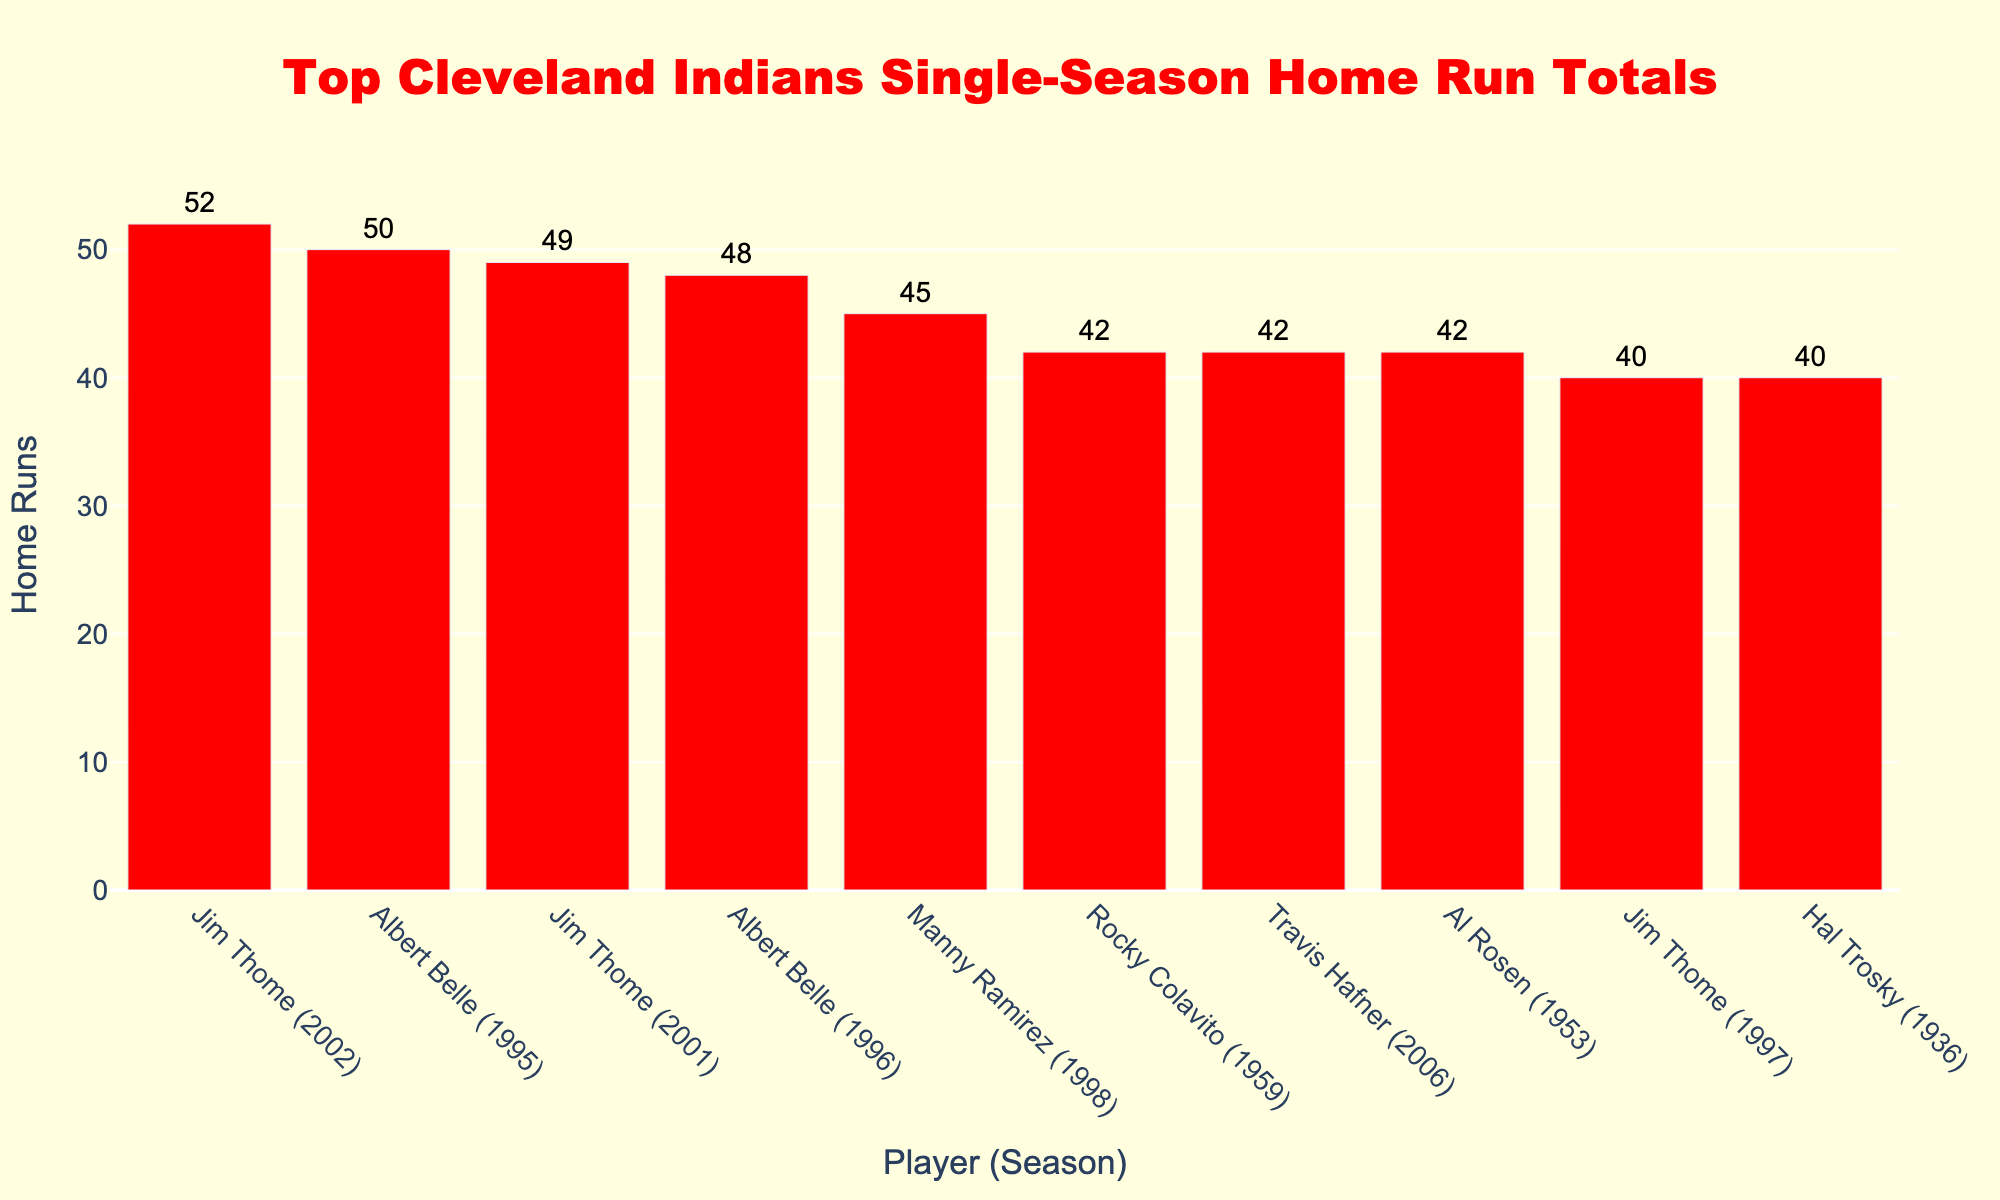Who holds the record for the most home runs in a single season for the Cleveland Indians? By inspecting the heights of the bars in the plot, it's clear that the tallest bar represents the player with the most home runs in a single season.
Answer: Jim Thome with 52 home runs in 2002 Which player appears twice in the Top 5 for single-season home runs? By examining the player names in the top 5 positions, one can identify any repeated names. Jim Thome appears twice.
Answer: Jim Thome What is the total number of home runs hit by Jim Thome in the seasons he is listed? Summing the home run totals for the seasons listed for Jim Thome (52 in 2002, 49 in 2001, and 40 in 1997) gives the result.
Answer: 141 Is there any player who hit 50 or more home runs in a single season, other than Jim Thome? By looking at the bars with home run totals of 50 or more, it is seen that Albert Belle, besides Jim Thome, hit 50 home runs in 1995.
Answer: Yes, Albert Belle Who hit more home runs in a single season: Manny Ramirez or Rocky Colavito? Comparing the heights of the bars for Manny Ramirez and Rocky Colavito shows that Manny Ramirez hit more home runs.
Answer: Manny Ramirez What is the difference in home runs between the top player (Jim Thome in 2002) and the fifth player (Manny Ramirez in 1998)? Subtracting Manny Ramirez's home run total (45) from Jim Thome's home run total (52) gives the difference.
Answer: 7 Which season had more home runs: Hal Trosky's 1936 or Al Rosen's 1953? By comparing the bars for Hal Trosky's 1936 and Al Rosen's 1953, it's evident that both seasons have the same total.
Answer: They are equal How many home runs were hit by Albert Belle in 1996 compared to 1995? By comparing the two bars for Albert Belle (50 in 1995 and 48 in 1996), we see he hit 2 fewer home runs in 1996.
Answer: 2 fewer in 1996 What is the average number of home runs hit by the players listed in the Top 10? Adding up all the home run totals (52 + 50 + 49 + 48 + 45 + 42 + 42 + 42 + 40 + 40) equals 450. Dividing the total by the number of entries (10) gives the average.
Answer: 45 What is the color used to represent the bars for the players’ home run totals? All the bars in the plot are colored red.
Answer: Red 